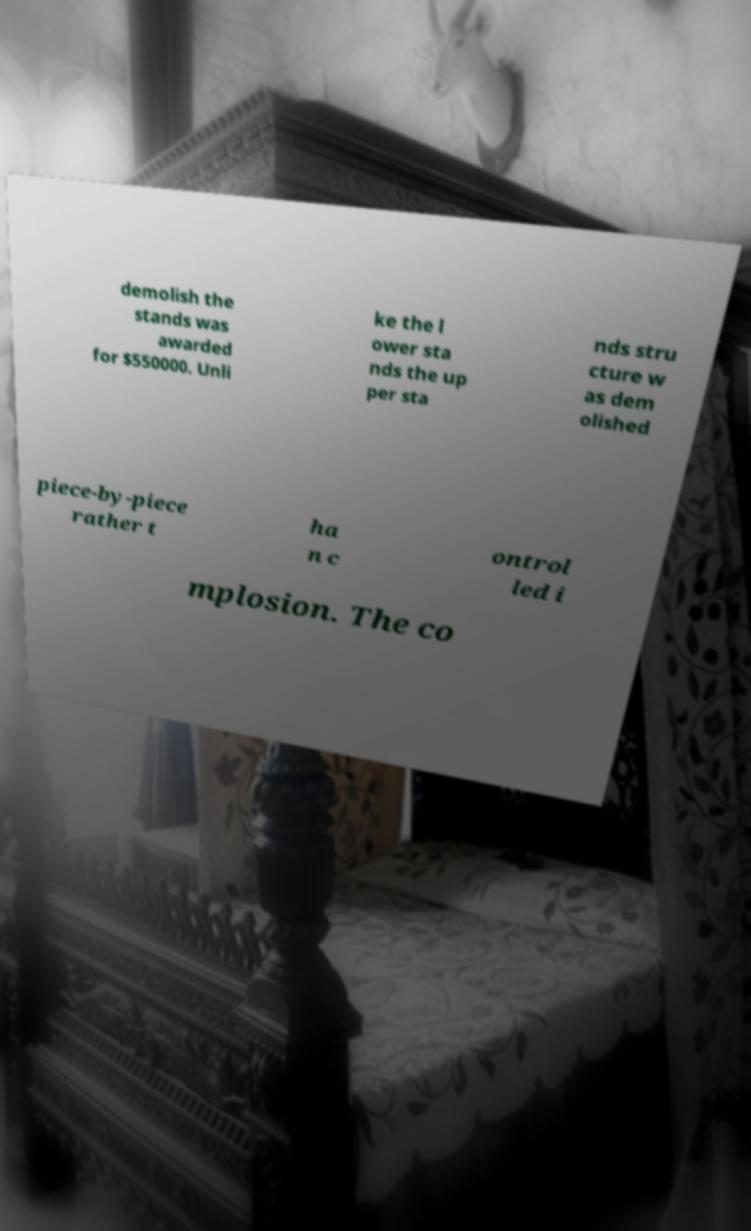Could you assist in decoding the text presented in this image and type it out clearly? demolish the stands was awarded for $550000. Unli ke the l ower sta nds the up per sta nds stru cture w as dem olished piece-by-piece rather t ha n c ontrol led i mplosion. The co 